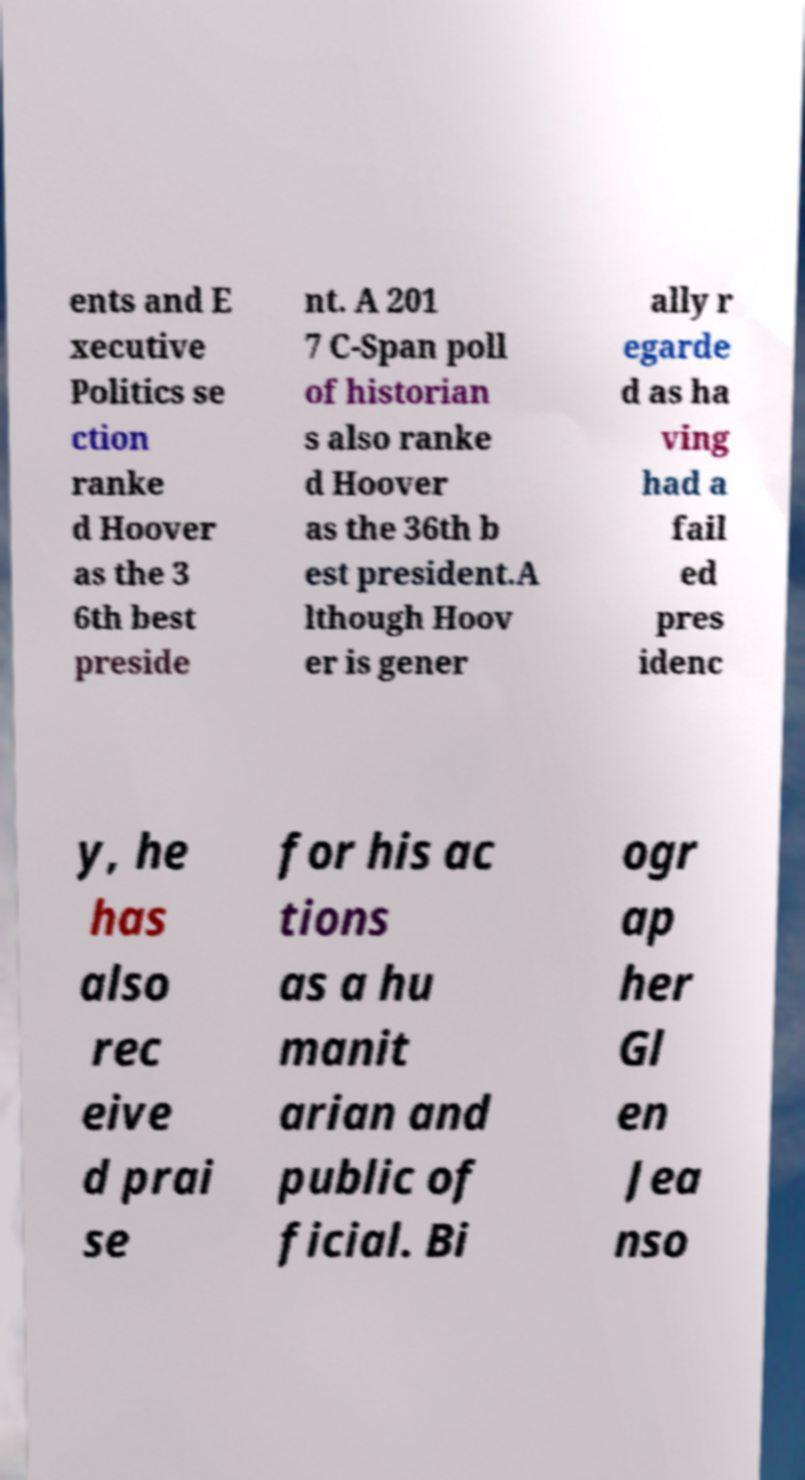Could you extract and type out the text from this image? ents and E xecutive Politics se ction ranke d Hoover as the 3 6th best preside nt. A 201 7 C-Span poll of historian s also ranke d Hoover as the 36th b est president.A lthough Hoov er is gener ally r egarde d as ha ving had a fail ed pres idenc y, he has also rec eive d prai se for his ac tions as a hu manit arian and public of ficial. Bi ogr ap her Gl en Jea nso 